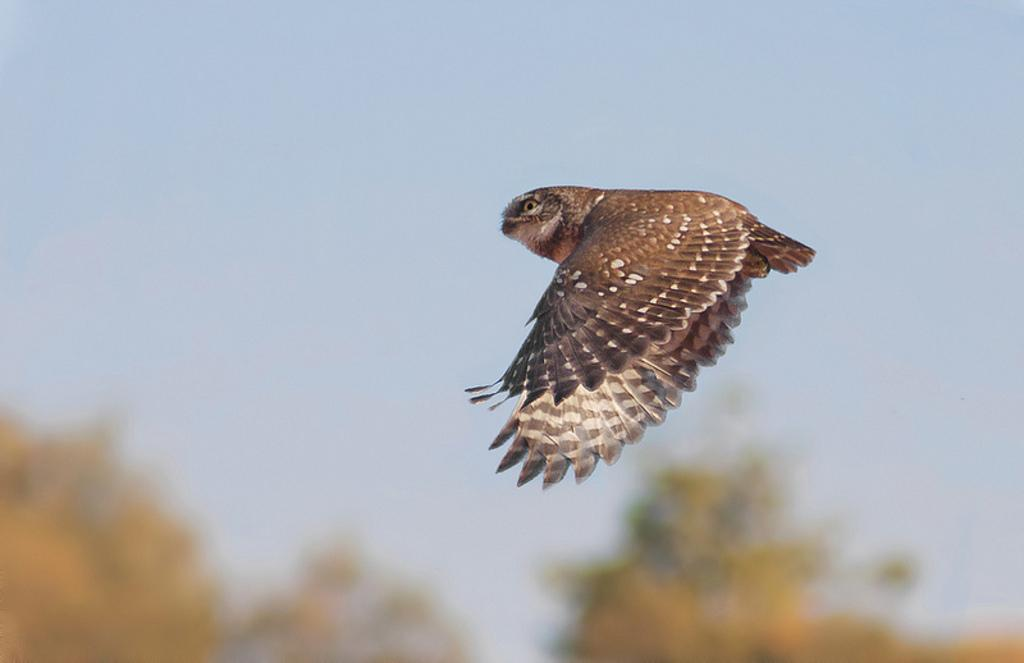What animal is present in the image? There is an owl in the image. What is the owl doing in the image? The owl is flying in the image. Where is the owl located in the image? The owl is in the sky in the image. What can be seen in the background of the image? There are trees in the background of the image. How would you describe the weather based on the image? The sky is clear in the image, suggesting good weather. How many dolls are playing the guitar in the image? There are no dolls or guitars present in the image; it features an owl flying in the sky. 